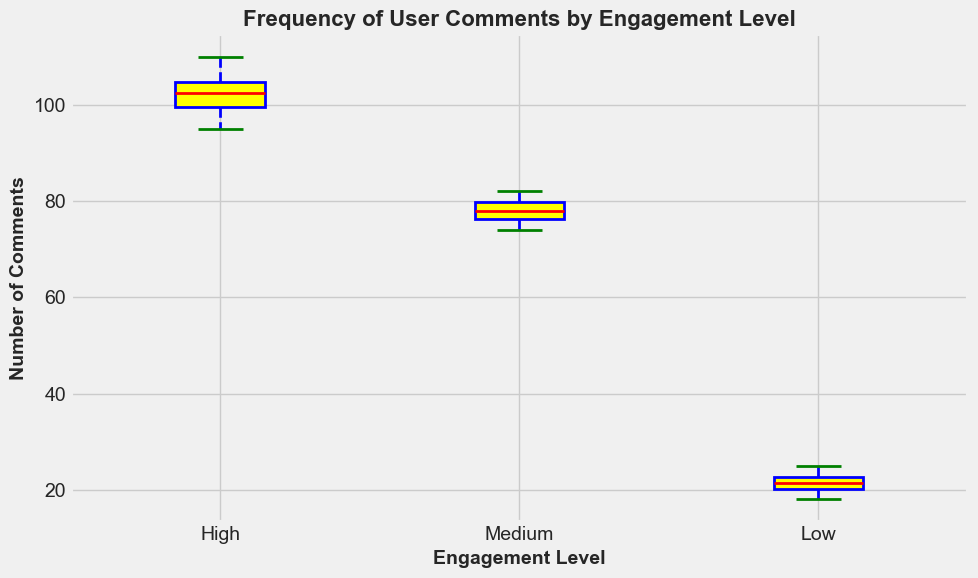What is the median number of comments for high engagement articles? The median is the middle value when the data points are arranged in ascending order. For high engagement articles, the sorted comments are: 95, 98, 99, 101, 102, 103, 104, 105, 108, 110. The median (middle) value is (102+103)/2 = 102.5.
Answer: 102.5 How does the median number of comments for medium engagement articles compare to high engagement articles? The median for medium engagement is calculated from the sorted list: 74, 75, 76, 77, 78, 78, 79, 80, 81, 82, which gives (78+78)/2 = 78. For high engagement, the median is 102.5. Therefore, the median for high engagement is greater than medium engagement.
Answer: High > Medium Which engagement group has the highest interquartile range (IQR) of comments? The IQR is calculated as the difference between the third quartile (Q3) and the first quartile (Q1). For high engagement, Q1=98.5 and Q3=105.5, so the IQR is 105.5-98.5=7. For medium engagement, Q1=75.75 and Q3=79.25, so the IQR is 79.25-75.75=3.5. For low engagement, Q1=19.25 and Q3=23, so the IQR is 23-19.25=3.75. High engagement has the highest IQR.
Answer: High Are there any outliers in the high engagement comments? Outliers are data points that fall outside 1.5 times the IQR (above Q3 or below Q1). For high engagement, Q1=98.5 and Q3=105.5 with IQR=7. Outliers lie beyond Q1-1.5*IQR and Q3+1.5*IQR, which are 88 and 116 respectively. All data points lie between these bounds, so there are no outliers.
Answer: No What is the average number of comments for low engagement articles? The average is the sum of the data divided by the number of data points. Sum of comments for low engagement: 20+22+18+25+24+21+19+23+22+21 = 195. There are 10 data points, so the average is 195/10 = 19.5.
Answer: 19.5 Which engagement level has the smallest range of comments? The range is calculated by subtracting the smallest value from the largest value. For high engagement, the range is 110-95 = 15. For medium engagement, the range is 82-74 = 8. For low engagement, the range is 25-18 = 7. The smallest range is for the low engagement level.
Answer: Low What is the most visually striking difference between the comments' distributions by engagement level? The most visually striking difference is the position of the median lines and the spread of data. High engagement articles have higher median values and a larger spread in comments compared to medium and low engagement articles, and noticeable differences in box heights and whisker lengths.
Answer: High engagement has higher medians and larger spread What's the difference in the median number of comments between medium and low engagement articles? The median for medium engagement comments is 78, and for low engagement comments, it is 21. The difference is 78 - 21 = 57.
Answer: 57 Which engagement level has the box with the most similar width for Q1 to Q3? Visually comparing the boxes, medium engagement has a relatively narrow box, indicating a smaller interquartile range, closely followed by low engagement. High engagement has the widest box.
Answer: Medium 